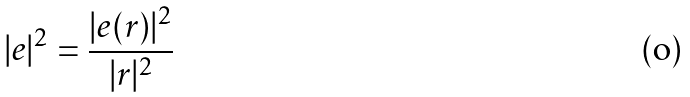<formula> <loc_0><loc_0><loc_500><loc_500>| e | ^ { 2 } = \frac { | e ( r ) | ^ { 2 } } { | r | ^ { 2 } }</formula> 